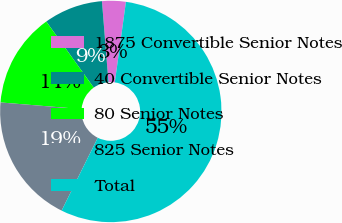Convert chart to OTSL. <chart><loc_0><loc_0><loc_500><loc_500><pie_chart><fcel>1875 Convertible Senior Notes<fcel>40 Convertible Senior Notes<fcel>80 Senior Notes<fcel>825 Senior Notes<fcel>Total<nl><fcel>3.46%<fcel>8.63%<fcel>13.8%<fcel>18.97%<fcel>55.15%<nl></chart> 